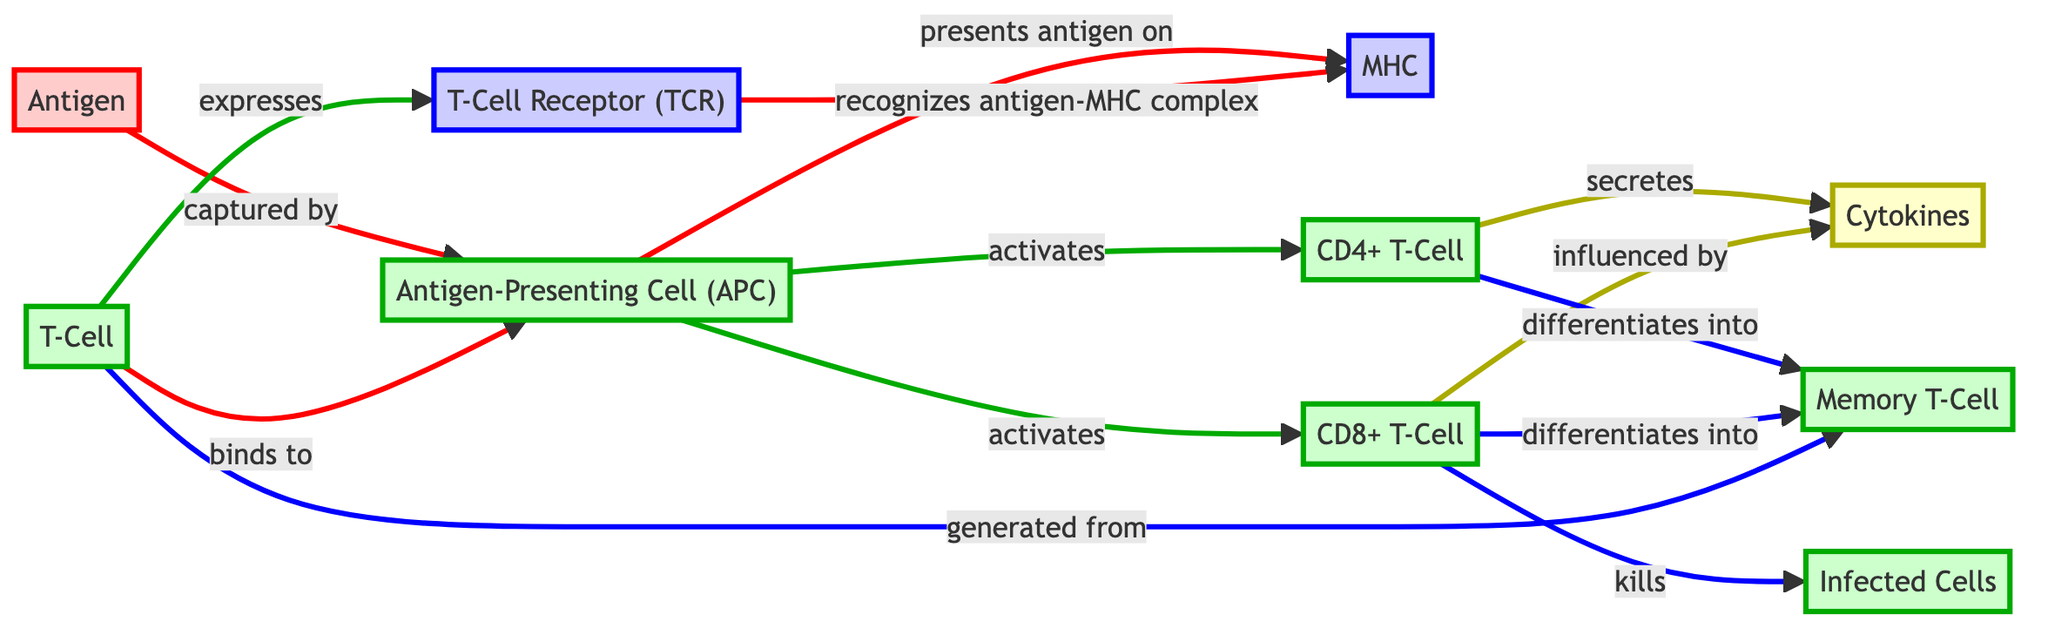What cells express T-Cell Receptor? The diagram shows that T-Cells express the T-Cell Receptor (TCR). The process is indicated by the arrow leading from T-Cell to T-Cell Receptor, making it clear that T-Cells are the cells that have this receptor.
Answer: T-Cells How many types of T-Cells are activated by the APC? The diagram highlights that the Antigen-Presenting Cell (APC) activates both CD4+ T-Cells and CD8+ T-Cells, shown by the two arrows leading from APC to these cells. Therefore, the total number of different T-Cell types activated is two.
Answer: 2 What do CD4+ T-Cells differentiate into? According to the diagram, CD4+ T-Cells differentiate into Memory T-Cells, which is indicated by the arrow connecting CD4 to Memory T-Cell.
Answer: Memory T-Cells Which cells are killed by CD8+ T-Cells? The diagram illustrates that CD8+ T-Cells kill Infected Cells, represented by the arrow that points from CD8 to Infected Cells, clarifying this direct action.
Answer: Infected Cells What molecule presents the antigen? The diagram indicates that the MHC presents the antigen, as the arrow shows the flow from the Antigen-Presenting Cell (APC) to the MHC labeled with the antigen. This directly points to MHC being the presenter.
Answer: MHC How are Cytokines involved in the immune response? The diagram details that Cytokines are secreted by CD4+ T-Cells and influence CD8+ T-Cells, shown by the arrows linking these nodes with Cytokines. This indicates their role in communication and activation in the immune response.
Answer: Secreted and Influenced What initiates the T-Cell activation process? The process of T-Cell activation starts with the binding of T-Cells to the Antigen-Presenting Cell (APC), which is the first step shown in the flow from APC to T-Cell in the diagram.
Answer: Antigen-Presenting Cell (APC) Which cells are generated from Memory T-Cells? The diagram states that T-Cells are generated from Memory T-Cells, indicated by the arrow showing this connection in the diagram's flow.
Answer: T-Cells What is the primary function of CD8+ T-Cells illustrated in the diagram? The diagram indicates that the primary function of CD8+ T-Cells is to kill Infected Cells, as depicted by the direct arrow from CD8+ T-Cell to Infected Cells.
Answer: Kill Infected Cells 